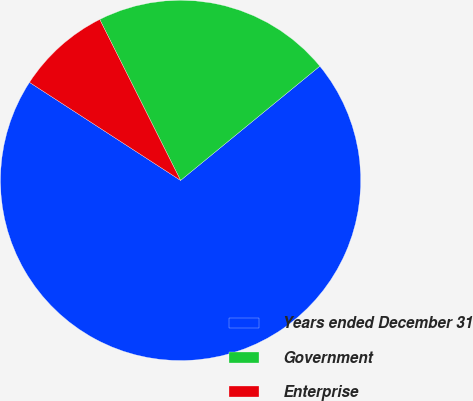Convert chart to OTSL. <chart><loc_0><loc_0><loc_500><loc_500><pie_chart><fcel>Years ended December 31<fcel>Government<fcel>Enterprise<nl><fcel>70.09%<fcel>21.47%<fcel>8.43%<nl></chart> 